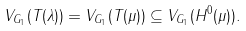Convert formula to latex. <formula><loc_0><loc_0><loc_500><loc_500>V _ { G _ { 1 } } ( T ( \lambda ) ) = V _ { G _ { 1 } } ( T ( \mu ) ) \subseteq V _ { G _ { 1 } } ( H ^ { 0 } ( \mu ) ) .</formula> 